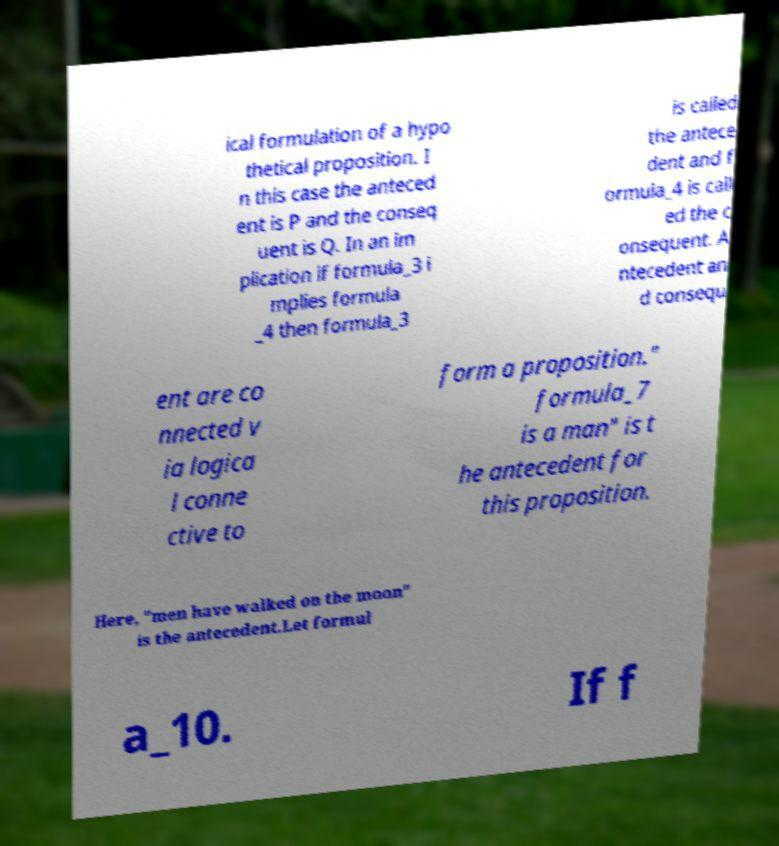There's text embedded in this image that I need extracted. Can you transcribe it verbatim? ical formulation of a hypo thetical proposition. I n this case the anteced ent is P and the conseq uent is Q. In an im plication if formula_3 i mplies formula _4 then formula_3 is called the antece dent and f ormula_4 is call ed the c onsequent. A ntecedent an d consequ ent are co nnected v ia logica l conne ctive to form a proposition." formula_7 is a man" is t he antecedent for this proposition. Here, "men have walked on the moon" is the antecedent.Let formul a_10. If f 